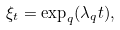<formula> <loc_0><loc_0><loc_500><loc_500>\xi _ { t } = \exp _ { q } ( \lambda _ { q } t ) ,</formula> 